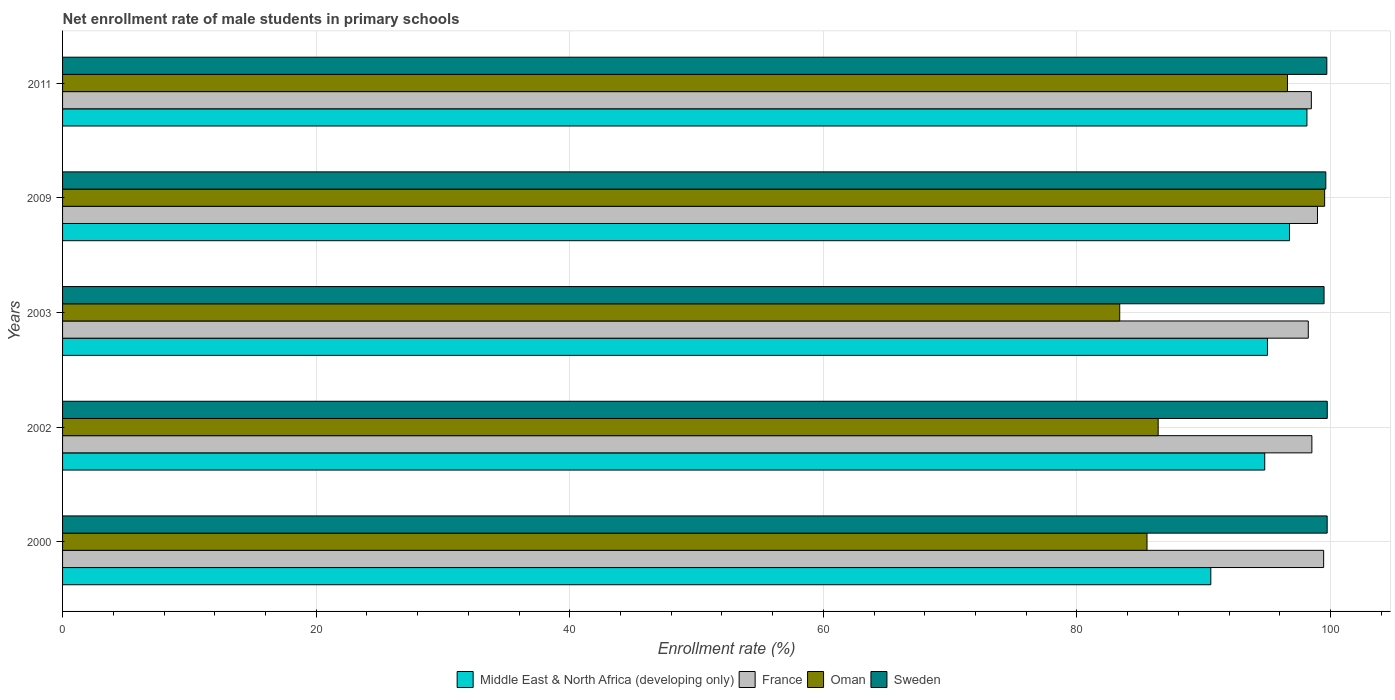How many different coloured bars are there?
Provide a short and direct response. 4. How many groups of bars are there?
Provide a short and direct response. 5. What is the label of the 2nd group of bars from the top?
Give a very brief answer. 2009. In how many cases, is the number of bars for a given year not equal to the number of legend labels?
Provide a short and direct response. 0. What is the net enrollment rate of male students in primary schools in France in 2002?
Provide a short and direct response. 98.53. Across all years, what is the maximum net enrollment rate of male students in primary schools in Sweden?
Offer a very short reply. 99.74. Across all years, what is the minimum net enrollment rate of male students in primary schools in France?
Provide a short and direct response. 98.24. In which year was the net enrollment rate of male students in primary schools in France maximum?
Your answer should be compact. 2000. What is the total net enrollment rate of male students in primary schools in Sweden in the graph?
Your answer should be very brief. 498.29. What is the difference between the net enrollment rate of male students in primary schools in France in 2003 and that in 2009?
Provide a succinct answer. -0.73. What is the difference between the net enrollment rate of male students in primary schools in Oman in 2009 and the net enrollment rate of male students in primary schools in France in 2011?
Offer a terse response. 1.05. What is the average net enrollment rate of male students in primary schools in Middle East & North Africa (developing only) per year?
Offer a terse response. 95.06. In the year 2002, what is the difference between the net enrollment rate of male students in primary schools in Oman and net enrollment rate of male students in primary schools in Middle East & North Africa (developing only)?
Keep it short and to the point. -8.4. In how many years, is the net enrollment rate of male students in primary schools in Sweden greater than 64 %?
Your answer should be very brief. 5. What is the ratio of the net enrollment rate of male students in primary schools in Sweden in 2000 to that in 2009?
Your answer should be very brief. 1. Is the net enrollment rate of male students in primary schools in Sweden in 2000 less than that in 2002?
Your answer should be compact. Yes. Is the difference between the net enrollment rate of male students in primary schools in Oman in 2002 and 2003 greater than the difference between the net enrollment rate of male students in primary schools in Middle East & North Africa (developing only) in 2002 and 2003?
Keep it short and to the point. Yes. What is the difference between the highest and the second highest net enrollment rate of male students in primary schools in Middle East & North Africa (developing only)?
Provide a succinct answer. 1.38. What is the difference between the highest and the lowest net enrollment rate of male students in primary schools in Oman?
Your answer should be very brief. 16.16. In how many years, is the net enrollment rate of male students in primary schools in Middle East & North Africa (developing only) greater than the average net enrollment rate of male students in primary schools in Middle East & North Africa (developing only) taken over all years?
Provide a short and direct response. 2. Is it the case that in every year, the sum of the net enrollment rate of male students in primary schools in Oman and net enrollment rate of male students in primary schools in France is greater than the sum of net enrollment rate of male students in primary schools in Middle East & North Africa (developing only) and net enrollment rate of male students in primary schools in Sweden?
Provide a succinct answer. No. What does the 4th bar from the top in 2002 represents?
Give a very brief answer. Middle East & North Africa (developing only). How many bars are there?
Your answer should be very brief. 20. Are all the bars in the graph horizontal?
Offer a terse response. Yes. How many years are there in the graph?
Ensure brevity in your answer.  5. Does the graph contain any zero values?
Offer a very short reply. No. Does the graph contain grids?
Ensure brevity in your answer.  Yes. Where does the legend appear in the graph?
Provide a short and direct response. Bottom center. How many legend labels are there?
Make the answer very short. 4. How are the legend labels stacked?
Ensure brevity in your answer.  Horizontal. What is the title of the graph?
Your response must be concise. Net enrollment rate of male students in primary schools. What is the label or title of the X-axis?
Ensure brevity in your answer.  Enrollment rate (%). What is the Enrollment rate (%) of Middle East & North Africa (developing only) in 2000?
Provide a succinct answer. 90.56. What is the Enrollment rate (%) of France in 2000?
Keep it short and to the point. 99.45. What is the Enrollment rate (%) of Oman in 2000?
Ensure brevity in your answer.  85.52. What is the Enrollment rate (%) of Sweden in 2000?
Make the answer very short. 99.73. What is the Enrollment rate (%) of Middle East & North Africa (developing only) in 2002?
Offer a terse response. 94.81. What is the Enrollment rate (%) in France in 2002?
Ensure brevity in your answer.  98.53. What is the Enrollment rate (%) in Oman in 2002?
Make the answer very short. 86.4. What is the Enrollment rate (%) of Sweden in 2002?
Your response must be concise. 99.74. What is the Enrollment rate (%) in Middle East & North Africa (developing only) in 2003?
Offer a very short reply. 95.02. What is the Enrollment rate (%) of France in 2003?
Offer a very short reply. 98.24. What is the Enrollment rate (%) of Oman in 2003?
Provide a short and direct response. 83.37. What is the Enrollment rate (%) in Sweden in 2003?
Offer a very short reply. 99.49. What is the Enrollment rate (%) in Middle East & North Africa (developing only) in 2009?
Offer a terse response. 96.76. What is the Enrollment rate (%) of France in 2009?
Provide a short and direct response. 98.97. What is the Enrollment rate (%) of Oman in 2009?
Provide a succinct answer. 99.53. What is the Enrollment rate (%) of Sweden in 2009?
Offer a terse response. 99.63. What is the Enrollment rate (%) in Middle East & North Africa (developing only) in 2011?
Give a very brief answer. 98.14. What is the Enrollment rate (%) of France in 2011?
Ensure brevity in your answer.  98.48. What is the Enrollment rate (%) in Oman in 2011?
Offer a terse response. 96.6. What is the Enrollment rate (%) of Sweden in 2011?
Your answer should be very brief. 99.7. Across all years, what is the maximum Enrollment rate (%) of Middle East & North Africa (developing only)?
Ensure brevity in your answer.  98.14. Across all years, what is the maximum Enrollment rate (%) of France?
Your answer should be very brief. 99.45. Across all years, what is the maximum Enrollment rate (%) in Oman?
Your answer should be very brief. 99.53. Across all years, what is the maximum Enrollment rate (%) in Sweden?
Make the answer very short. 99.74. Across all years, what is the minimum Enrollment rate (%) of Middle East & North Africa (developing only)?
Make the answer very short. 90.56. Across all years, what is the minimum Enrollment rate (%) in France?
Your answer should be compact. 98.24. Across all years, what is the minimum Enrollment rate (%) of Oman?
Provide a succinct answer. 83.37. Across all years, what is the minimum Enrollment rate (%) of Sweden?
Your answer should be very brief. 99.49. What is the total Enrollment rate (%) of Middle East & North Africa (developing only) in the graph?
Provide a short and direct response. 475.28. What is the total Enrollment rate (%) of France in the graph?
Ensure brevity in your answer.  493.67. What is the total Enrollment rate (%) of Oman in the graph?
Give a very brief answer. 451.43. What is the total Enrollment rate (%) in Sweden in the graph?
Your response must be concise. 498.29. What is the difference between the Enrollment rate (%) of Middle East & North Africa (developing only) in 2000 and that in 2002?
Offer a terse response. -4.25. What is the difference between the Enrollment rate (%) of France in 2000 and that in 2002?
Your answer should be compact. 0.93. What is the difference between the Enrollment rate (%) in Oman in 2000 and that in 2002?
Provide a succinct answer. -0.88. What is the difference between the Enrollment rate (%) in Sweden in 2000 and that in 2002?
Keep it short and to the point. -0.01. What is the difference between the Enrollment rate (%) of Middle East & North Africa (developing only) in 2000 and that in 2003?
Your answer should be compact. -4.47. What is the difference between the Enrollment rate (%) in France in 2000 and that in 2003?
Make the answer very short. 1.21. What is the difference between the Enrollment rate (%) in Oman in 2000 and that in 2003?
Your answer should be very brief. 2.15. What is the difference between the Enrollment rate (%) of Sweden in 2000 and that in 2003?
Your answer should be compact. 0.25. What is the difference between the Enrollment rate (%) of Middle East & North Africa (developing only) in 2000 and that in 2009?
Your answer should be very brief. -6.2. What is the difference between the Enrollment rate (%) of France in 2000 and that in 2009?
Ensure brevity in your answer.  0.49. What is the difference between the Enrollment rate (%) in Oman in 2000 and that in 2009?
Give a very brief answer. -14.01. What is the difference between the Enrollment rate (%) in Sweden in 2000 and that in 2009?
Keep it short and to the point. 0.11. What is the difference between the Enrollment rate (%) of Middle East & North Africa (developing only) in 2000 and that in 2011?
Give a very brief answer. -7.58. What is the difference between the Enrollment rate (%) in France in 2000 and that in 2011?
Make the answer very short. 0.97. What is the difference between the Enrollment rate (%) in Oman in 2000 and that in 2011?
Offer a very short reply. -11.08. What is the difference between the Enrollment rate (%) of Sweden in 2000 and that in 2011?
Keep it short and to the point. 0.03. What is the difference between the Enrollment rate (%) of Middle East & North Africa (developing only) in 2002 and that in 2003?
Provide a succinct answer. -0.21. What is the difference between the Enrollment rate (%) of France in 2002 and that in 2003?
Keep it short and to the point. 0.28. What is the difference between the Enrollment rate (%) of Oman in 2002 and that in 2003?
Your answer should be compact. 3.03. What is the difference between the Enrollment rate (%) of Sweden in 2002 and that in 2003?
Provide a succinct answer. 0.25. What is the difference between the Enrollment rate (%) of Middle East & North Africa (developing only) in 2002 and that in 2009?
Give a very brief answer. -1.95. What is the difference between the Enrollment rate (%) of France in 2002 and that in 2009?
Your response must be concise. -0.44. What is the difference between the Enrollment rate (%) in Oman in 2002 and that in 2009?
Make the answer very short. -13.13. What is the difference between the Enrollment rate (%) of Sweden in 2002 and that in 2009?
Your answer should be very brief. 0.11. What is the difference between the Enrollment rate (%) in Middle East & North Africa (developing only) in 2002 and that in 2011?
Provide a short and direct response. -3.33. What is the difference between the Enrollment rate (%) of France in 2002 and that in 2011?
Provide a succinct answer. 0.04. What is the difference between the Enrollment rate (%) of Oman in 2002 and that in 2011?
Your answer should be very brief. -10.2. What is the difference between the Enrollment rate (%) of Sweden in 2002 and that in 2011?
Your answer should be compact. 0.03. What is the difference between the Enrollment rate (%) in Middle East & North Africa (developing only) in 2003 and that in 2009?
Your response must be concise. -1.74. What is the difference between the Enrollment rate (%) of France in 2003 and that in 2009?
Ensure brevity in your answer.  -0.73. What is the difference between the Enrollment rate (%) in Oman in 2003 and that in 2009?
Ensure brevity in your answer.  -16.16. What is the difference between the Enrollment rate (%) in Sweden in 2003 and that in 2009?
Ensure brevity in your answer.  -0.14. What is the difference between the Enrollment rate (%) of Middle East & North Africa (developing only) in 2003 and that in 2011?
Your response must be concise. -3.11. What is the difference between the Enrollment rate (%) of France in 2003 and that in 2011?
Make the answer very short. -0.24. What is the difference between the Enrollment rate (%) of Oman in 2003 and that in 2011?
Keep it short and to the point. -13.23. What is the difference between the Enrollment rate (%) of Sweden in 2003 and that in 2011?
Your response must be concise. -0.22. What is the difference between the Enrollment rate (%) in Middle East & North Africa (developing only) in 2009 and that in 2011?
Offer a terse response. -1.38. What is the difference between the Enrollment rate (%) of France in 2009 and that in 2011?
Make the answer very short. 0.48. What is the difference between the Enrollment rate (%) of Oman in 2009 and that in 2011?
Offer a very short reply. 2.93. What is the difference between the Enrollment rate (%) of Sweden in 2009 and that in 2011?
Your answer should be compact. -0.08. What is the difference between the Enrollment rate (%) of Middle East & North Africa (developing only) in 2000 and the Enrollment rate (%) of France in 2002?
Give a very brief answer. -7.97. What is the difference between the Enrollment rate (%) in Middle East & North Africa (developing only) in 2000 and the Enrollment rate (%) in Oman in 2002?
Offer a terse response. 4.15. What is the difference between the Enrollment rate (%) in Middle East & North Africa (developing only) in 2000 and the Enrollment rate (%) in Sweden in 2002?
Keep it short and to the point. -9.18. What is the difference between the Enrollment rate (%) of France in 2000 and the Enrollment rate (%) of Oman in 2002?
Make the answer very short. 13.05. What is the difference between the Enrollment rate (%) in France in 2000 and the Enrollment rate (%) in Sweden in 2002?
Offer a terse response. -0.29. What is the difference between the Enrollment rate (%) in Oman in 2000 and the Enrollment rate (%) in Sweden in 2002?
Your answer should be very brief. -14.21. What is the difference between the Enrollment rate (%) in Middle East & North Africa (developing only) in 2000 and the Enrollment rate (%) in France in 2003?
Keep it short and to the point. -7.69. What is the difference between the Enrollment rate (%) in Middle East & North Africa (developing only) in 2000 and the Enrollment rate (%) in Oman in 2003?
Provide a short and direct response. 7.18. What is the difference between the Enrollment rate (%) of Middle East & North Africa (developing only) in 2000 and the Enrollment rate (%) of Sweden in 2003?
Provide a succinct answer. -8.93. What is the difference between the Enrollment rate (%) of France in 2000 and the Enrollment rate (%) of Oman in 2003?
Provide a succinct answer. 16.08. What is the difference between the Enrollment rate (%) of France in 2000 and the Enrollment rate (%) of Sweden in 2003?
Offer a terse response. -0.03. What is the difference between the Enrollment rate (%) of Oman in 2000 and the Enrollment rate (%) of Sweden in 2003?
Keep it short and to the point. -13.96. What is the difference between the Enrollment rate (%) in Middle East & North Africa (developing only) in 2000 and the Enrollment rate (%) in France in 2009?
Ensure brevity in your answer.  -8.41. What is the difference between the Enrollment rate (%) of Middle East & North Africa (developing only) in 2000 and the Enrollment rate (%) of Oman in 2009?
Provide a short and direct response. -8.98. What is the difference between the Enrollment rate (%) of Middle East & North Africa (developing only) in 2000 and the Enrollment rate (%) of Sweden in 2009?
Offer a terse response. -9.07. What is the difference between the Enrollment rate (%) of France in 2000 and the Enrollment rate (%) of Oman in 2009?
Keep it short and to the point. -0.08. What is the difference between the Enrollment rate (%) in France in 2000 and the Enrollment rate (%) in Sweden in 2009?
Keep it short and to the point. -0.17. What is the difference between the Enrollment rate (%) in Oman in 2000 and the Enrollment rate (%) in Sweden in 2009?
Keep it short and to the point. -14.1. What is the difference between the Enrollment rate (%) of Middle East & North Africa (developing only) in 2000 and the Enrollment rate (%) of France in 2011?
Your response must be concise. -7.93. What is the difference between the Enrollment rate (%) of Middle East & North Africa (developing only) in 2000 and the Enrollment rate (%) of Oman in 2011?
Make the answer very short. -6.05. What is the difference between the Enrollment rate (%) in Middle East & North Africa (developing only) in 2000 and the Enrollment rate (%) in Sweden in 2011?
Offer a very short reply. -9.15. What is the difference between the Enrollment rate (%) of France in 2000 and the Enrollment rate (%) of Oman in 2011?
Keep it short and to the point. 2.85. What is the difference between the Enrollment rate (%) in France in 2000 and the Enrollment rate (%) in Sweden in 2011?
Your answer should be compact. -0.25. What is the difference between the Enrollment rate (%) of Oman in 2000 and the Enrollment rate (%) of Sweden in 2011?
Your answer should be very brief. -14.18. What is the difference between the Enrollment rate (%) in Middle East & North Africa (developing only) in 2002 and the Enrollment rate (%) in France in 2003?
Give a very brief answer. -3.43. What is the difference between the Enrollment rate (%) of Middle East & North Africa (developing only) in 2002 and the Enrollment rate (%) of Oman in 2003?
Give a very brief answer. 11.44. What is the difference between the Enrollment rate (%) in Middle East & North Africa (developing only) in 2002 and the Enrollment rate (%) in Sweden in 2003?
Your answer should be compact. -4.68. What is the difference between the Enrollment rate (%) in France in 2002 and the Enrollment rate (%) in Oman in 2003?
Offer a terse response. 15.15. What is the difference between the Enrollment rate (%) in France in 2002 and the Enrollment rate (%) in Sweden in 2003?
Offer a terse response. -0.96. What is the difference between the Enrollment rate (%) in Oman in 2002 and the Enrollment rate (%) in Sweden in 2003?
Give a very brief answer. -13.08. What is the difference between the Enrollment rate (%) of Middle East & North Africa (developing only) in 2002 and the Enrollment rate (%) of France in 2009?
Offer a very short reply. -4.16. What is the difference between the Enrollment rate (%) of Middle East & North Africa (developing only) in 2002 and the Enrollment rate (%) of Oman in 2009?
Keep it short and to the point. -4.72. What is the difference between the Enrollment rate (%) of Middle East & North Africa (developing only) in 2002 and the Enrollment rate (%) of Sweden in 2009?
Keep it short and to the point. -4.82. What is the difference between the Enrollment rate (%) in France in 2002 and the Enrollment rate (%) in Oman in 2009?
Ensure brevity in your answer.  -1.01. What is the difference between the Enrollment rate (%) of France in 2002 and the Enrollment rate (%) of Sweden in 2009?
Keep it short and to the point. -1.1. What is the difference between the Enrollment rate (%) of Oman in 2002 and the Enrollment rate (%) of Sweden in 2009?
Provide a short and direct response. -13.22. What is the difference between the Enrollment rate (%) of Middle East & North Africa (developing only) in 2002 and the Enrollment rate (%) of France in 2011?
Provide a succinct answer. -3.68. What is the difference between the Enrollment rate (%) of Middle East & North Africa (developing only) in 2002 and the Enrollment rate (%) of Oman in 2011?
Provide a short and direct response. -1.79. What is the difference between the Enrollment rate (%) in Middle East & North Africa (developing only) in 2002 and the Enrollment rate (%) in Sweden in 2011?
Provide a succinct answer. -4.9. What is the difference between the Enrollment rate (%) in France in 2002 and the Enrollment rate (%) in Oman in 2011?
Your answer should be compact. 1.92. What is the difference between the Enrollment rate (%) in France in 2002 and the Enrollment rate (%) in Sweden in 2011?
Keep it short and to the point. -1.18. What is the difference between the Enrollment rate (%) in Oman in 2002 and the Enrollment rate (%) in Sweden in 2011?
Offer a terse response. -13.3. What is the difference between the Enrollment rate (%) of Middle East & North Africa (developing only) in 2003 and the Enrollment rate (%) of France in 2009?
Ensure brevity in your answer.  -3.94. What is the difference between the Enrollment rate (%) of Middle East & North Africa (developing only) in 2003 and the Enrollment rate (%) of Oman in 2009?
Offer a very short reply. -4.51. What is the difference between the Enrollment rate (%) in Middle East & North Africa (developing only) in 2003 and the Enrollment rate (%) in Sweden in 2009?
Provide a short and direct response. -4.6. What is the difference between the Enrollment rate (%) of France in 2003 and the Enrollment rate (%) of Oman in 2009?
Your answer should be very brief. -1.29. What is the difference between the Enrollment rate (%) in France in 2003 and the Enrollment rate (%) in Sweden in 2009?
Give a very brief answer. -1.38. What is the difference between the Enrollment rate (%) in Oman in 2003 and the Enrollment rate (%) in Sweden in 2009?
Your response must be concise. -16.25. What is the difference between the Enrollment rate (%) of Middle East & North Africa (developing only) in 2003 and the Enrollment rate (%) of France in 2011?
Offer a very short reply. -3.46. What is the difference between the Enrollment rate (%) of Middle East & North Africa (developing only) in 2003 and the Enrollment rate (%) of Oman in 2011?
Make the answer very short. -1.58. What is the difference between the Enrollment rate (%) of Middle East & North Africa (developing only) in 2003 and the Enrollment rate (%) of Sweden in 2011?
Give a very brief answer. -4.68. What is the difference between the Enrollment rate (%) of France in 2003 and the Enrollment rate (%) of Oman in 2011?
Your answer should be compact. 1.64. What is the difference between the Enrollment rate (%) in France in 2003 and the Enrollment rate (%) in Sweden in 2011?
Give a very brief answer. -1.46. What is the difference between the Enrollment rate (%) in Oman in 2003 and the Enrollment rate (%) in Sweden in 2011?
Keep it short and to the point. -16.33. What is the difference between the Enrollment rate (%) of Middle East & North Africa (developing only) in 2009 and the Enrollment rate (%) of France in 2011?
Give a very brief answer. -1.72. What is the difference between the Enrollment rate (%) in Middle East & North Africa (developing only) in 2009 and the Enrollment rate (%) in Oman in 2011?
Make the answer very short. 0.16. What is the difference between the Enrollment rate (%) in Middle East & North Africa (developing only) in 2009 and the Enrollment rate (%) in Sweden in 2011?
Ensure brevity in your answer.  -2.94. What is the difference between the Enrollment rate (%) of France in 2009 and the Enrollment rate (%) of Oman in 2011?
Make the answer very short. 2.37. What is the difference between the Enrollment rate (%) of France in 2009 and the Enrollment rate (%) of Sweden in 2011?
Provide a succinct answer. -0.74. What is the difference between the Enrollment rate (%) in Oman in 2009 and the Enrollment rate (%) in Sweden in 2011?
Ensure brevity in your answer.  -0.17. What is the average Enrollment rate (%) in Middle East & North Africa (developing only) per year?
Your answer should be compact. 95.06. What is the average Enrollment rate (%) of France per year?
Keep it short and to the point. 98.73. What is the average Enrollment rate (%) in Oman per year?
Offer a terse response. 90.29. What is the average Enrollment rate (%) in Sweden per year?
Offer a terse response. 99.66. In the year 2000, what is the difference between the Enrollment rate (%) of Middle East & North Africa (developing only) and Enrollment rate (%) of France?
Your answer should be very brief. -8.9. In the year 2000, what is the difference between the Enrollment rate (%) of Middle East & North Africa (developing only) and Enrollment rate (%) of Oman?
Ensure brevity in your answer.  5.03. In the year 2000, what is the difference between the Enrollment rate (%) in Middle East & North Africa (developing only) and Enrollment rate (%) in Sweden?
Provide a succinct answer. -9.18. In the year 2000, what is the difference between the Enrollment rate (%) of France and Enrollment rate (%) of Oman?
Offer a very short reply. 13.93. In the year 2000, what is the difference between the Enrollment rate (%) in France and Enrollment rate (%) in Sweden?
Provide a succinct answer. -0.28. In the year 2000, what is the difference between the Enrollment rate (%) of Oman and Enrollment rate (%) of Sweden?
Offer a very short reply. -14.21. In the year 2002, what is the difference between the Enrollment rate (%) of Middle East & North Africa (developing only) and Enrollment rate (%) of France?
Offer a very short reply. -3.72. In the year 2002, what is the difference between the Enrollment rate (%) of Middle East & North Africa (developing only) and Enrollment rate (%) of Oman?
Your answer should be compact. 8.4. In the year 2002, what is the difference between the Enrollment rate (%) of Middle East & North Africa (developing only) and Enrollment rate (%) of Sweden?
Your answer should be compact. -4.93. In the year 2002, what is the difference between the Enrollment rate (%) in France and Enrollment rate (%) in Oman?
Make the answer very short. 12.12. In the year 2002, what is the difference between the Enrollment rate (%) of France and Enrollment rate (%) of Sweden?
Provide a succinct answer. -1.21. In the year 2002, what is the difference between the Enrollment rate (%) in Oman and Enrollment rate (%) in Sweden?
Keep it short and to the point. -13.33. In the year 2003, what is the difference between the Enrollment rate (%) of Middle East & North Africa (developing only) and Enrollment rate (%) of France?
Offer a very short reply. -3.22. In the year 2003, what is the difference between the Enrollment rate (%) of Middle East & North Africa (developing only) and Enrollment rate (%) of Oman?
Keep it short and to the point. 11.65. In the year 2003, what is the difference between the Enrollment rate (%) in Middle East & North Africa (developing only) and Enrollment rate (%) in Sweden?
Offer a terse response. -4.46. In the year 2003, what is the difference between the Enrollment rate (%) in France and Enrollment rate (%) in Oman?
Your answer should be very brief. 14.87. In the year 2003, what is the difference between the Enrollment rate (%) of France and Enrollment rate (%) of Sweden?
Keep it short and to the point. -1.25. In the year 2003, what is the difference between the Enrollment rate (%) in Oman and Enrollment rate (%) in Sweden?
Your answer should be compact. -16.12. In the year 2009, what is the difference between the Enrollment rate (%) of Middle East & North Africa (developing only) and Enrollment rate (%) of France?
Offer a terse response. -2.21. In the year 2009, what is the difference between the Enrollment rate (%) of Middle East & North Africa (developing only) and Enrollment rate (%) of Oman?
Your answer should be compact. -2.77. In the year 2009, what is the difference between the Enrollment rate (%) of Middle East & North Africa (developing only) and Enrollment rate (%) of Sweden?
Your answer should be very brief. -2.87. In the year 2009, what is the difference between the Enrollment rate (%) in France and Enrollment rate (%) in Oman?
Give a very brief answer. -0.56. In the year 2009, what is the difference between the Enrollment rate (%) in France and Enrollment rate (%) in Sweden?
Keep it short and to the point. -0.66. In the year 2009, what is the difference between the Enrollment rate (%) in Oman and Enrollment rate (%) in Sweden?
Offer a terse response. -0.09. In the year 2011, what is the difference between the Enrollment rate (%) in Middle East & North Africa (developing only) and Enrollment rate (%) in France?
Give a very brief answer. -0.35. In the year 2011, what is the difference between the Enrollment rate (%) in Middle East & North Africa (developing only) and Enrollment rate (%) in Oman?
Your answer should be very brief. 1.53. In the year 2011, what is the difference between the Enrollment rate (%) in Middle East & North Africa (developing only) and Enrollment rate (%) in Sweden?
Provide a short and direct response. -1.57. In the year 2011, what is the difference between the Enrollment rate (%) in France and Enrollment rate (%) in Oman?
Provide a short and direct response. 1.88. In the year 2011, what is the difference between the Enrollment rate (%) of France and Enrollment rate (%) of Sweden?
Your response must be concise. -1.22. In the year 2011, what is the difference between the Enrollment rate (%) in Oman and Enrollment rate (%) in Sweden?
Provide a short and direct response. -3.1. What is the ratio of the Enrollment rate (%) of Middle East & North Africa (developing only) in 2000 to that in 2002?
Your answer should be compact. 0.96. What is the ratio of the Enrollment rate (%) of France in 2000 to that in 2002?
Keep it short and to the point. 1.01. What is the ratio of the Enrollment rate (%) of Middle East & North Africa (developing only) in 2000 to that in 2003?
Ensure brevity in your answer.  0.95. What is the ratio of the Enrollment rate (%) of France in 2000 to that in 2003?
Keep it short and to the point. 1.01. What is the ratio of the Enrollment rate (%) of Oman in 2000 to that in 2003?
Your response must be concise. 1.03. What is the ratio of the Enrollment rate (%) of Sweden in 2000 to that in 2003?
Keep it short and to the point. 1. What is the ratio of the Enrollment rate (%) of Middle East & North Africa (developing only) in 2000 to that in 2009?
Offer a terse response. 0.94. What is the ratio of the Enrollment rate (%) in Oman in 2000 to that in 2009?
Provide a succinct answer. 0.86. What is the ratio of the Enrollment rate (%) of Middle East & North Africa (developing only) in 2000 to that in 2011?
Offer a terse response. 0.92. What is the ratio of the Enrollment rate (%) in France in 2000 to that in 2011?
Your response must be concise. 1.01. What is the ratio of the Enrollment rate (%) in Oman in 2000 to that in 2011?
Give a very brief answer. 0.89. What is the ratio of the Enrollment rate (%) of Sweden in 2000 to that in 2011?
Your answer should be very brief. 1. What is the ratio of the Enrollment rate (%) of Middle East & North Africa (developing only) in 2002 to that in 2003?
Your answer should be compact. 1. What is the ratio of the Enrollment rate (%) in France in 2002 to that in 2003?
Provide a short and direct response. 1. What is the ratio of the Enrollment rate (%) of Oman in 2002 to that in 2003?
Offer a terse response. 1.04. What is the ratio of the Enrollment rate (%) of Sweden in 2002 to that in 2003?
Keep it short and to the point. 1. What is the ratio of the Enrollment rate (%) in Middle East & North Africa (developing only) in 2002 to that in 2009?
Provide a short and direct response. 0.98. What is the ratio of the Enrollment rate (%) in Oman in 2002 to that in 2009?
Your answer should be very brief. 0.87. What is the ratio of the Enrollment rate (%) of Sweden in 2002 to that in 2009?
Keep it short and to the point. 1. What is the ratio of the Enrollment rate (%) of Middle East & North Africa (developing only) in 2002 to that in 2011?
Offer a very short reply. 0.97. What is the ratio of the Enrollment rate (%) in France in 2002 to that in 2011?
Make the answer very short. 1. What is the ratio of the Enrollment rate (%) in Oman in 2002 to that in 2011?
Keep it short and to the point. 0.89. What is the ratio of the Enrollment rate (%) of Sweden in 2002 to that in 2011?
Provide a short and direct response. 1. What is the ratio of the Enrollment rate (%) in Oman in 2003 to that in 2009?
Provide a short and direct response. 0.84. What is the ratio of the Enrollment rate (%) in Sweden in 2003 to that in 2009?
Your answer should be very brief. 1. What is the ratio of the Enrollment rate (%) of Middle East & North Africa (developing only) in 2003 to that in 2011?
Provide a short and direct response. 0.97. What is the ratio of the Enrollment rate (%) in Oman in 2003 to that in 2011?
Give a very brief answer. 0.86. What is the ratio of the Enrollment rate (%) in Sweden in 2003 to that in 2011?
Your answer should be very brief. 1. What is the ratio of the Enrollment rate (%) in Middle East & North Africa (developing only) in 2009 to that in 2011?
Provide a succinct answer. 0.99. What is the ratio of the Enrollment rate (%) of France in 2009 to that in 2011?
Your answer should be compact. 1. What is the ratio of the Enrollment rate (%) of Oman in 2009 to that in 2011?
Offer a terse response. 1.03. What is the difference between the highest and the second highest Enrollment rate (%) in Middle East & North Africa (developing only)?
Offer a terse response. 1.38. What is the difference between the highest and the second highest Enrollment rate (%) of France?
Your answer should be compact. 0.49. What is the difference between the highest and the second highest Enrollment rate (%) of Oman?
Offer a very short reply. 2.93. What is the difference between the highest and the second highest Enrollment rate (%) in Sweden?
Your answer should be very brief. 0.01. What is the difference between the highest and the lowest Enrollment rate (%) in Middle East & North Africa (developing only)?
Offer a terse response. 7.58. What is the difference between the highest and the lowest Enrollment rate (%) of France?
Offer a terse response. 1.21. What is the difference between the highest and the lowest Enrollment rate (%) of Oman?
Offer a terse response. 16.16. What is the difference between the highest and the lowest Enrollment rate (%) in Sweden?
Provide a short and direct response. 0.25. 